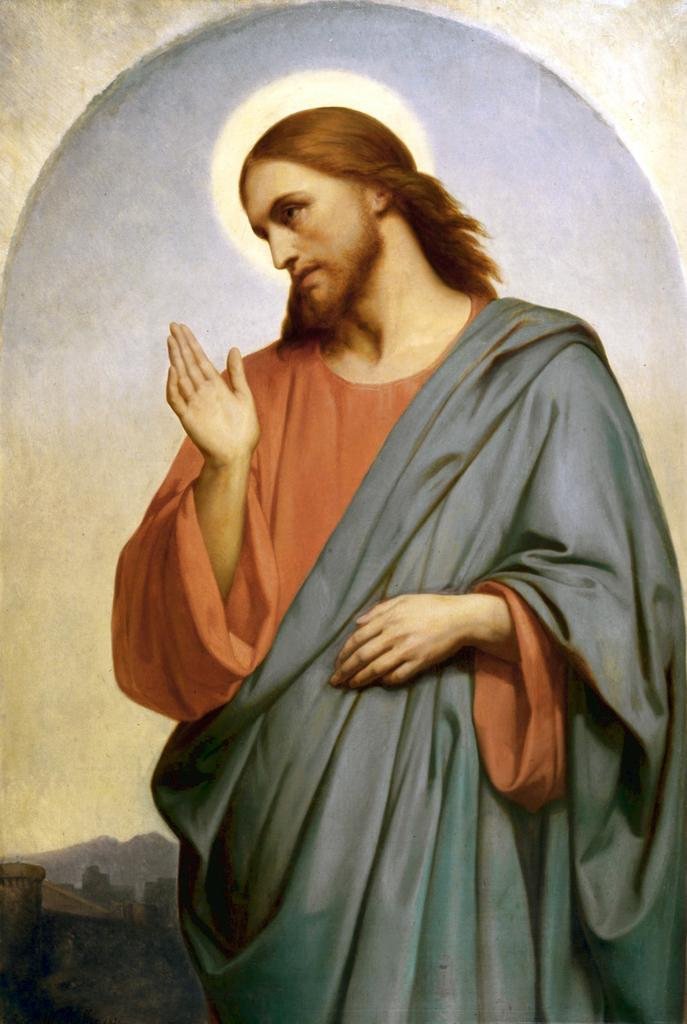What is the main subject of the image? There is a person in the image. What type of train can be seen in the background of the image? There is no train present in the image; it only features a person. Is the person holding a rifle in the image? There is no rifle present in the image; it only features a person. 